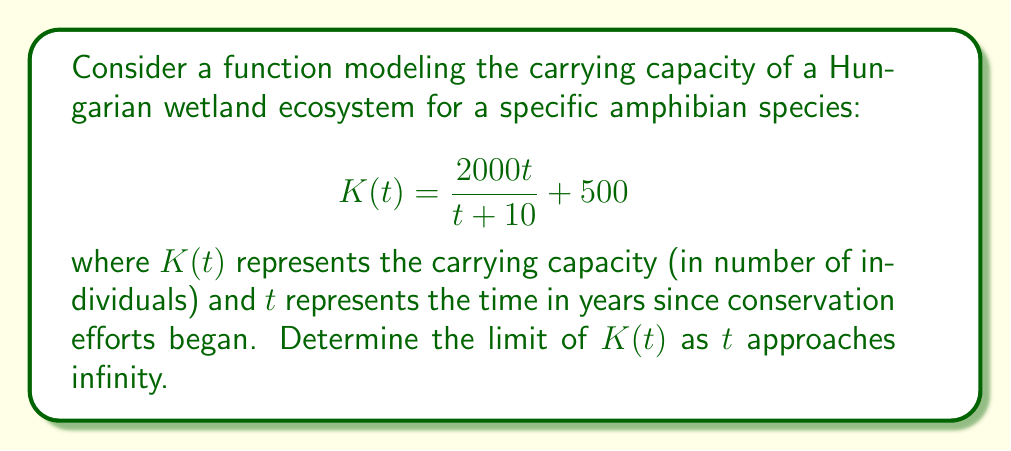Give your solution to this math problem. To find the limit of $K(t)$ as $t$ approaches infinity, we can follow these steps:

1) First, let's examine the structure of the function:
   $$K(t) = \frac{2000t}{t + 10} + 500$$

2) We can separate this into two parts:
   $$\lim_{t \to \infty} K(t) = \lim_{t \to \infty} \left(\frac{2000t}{t + 10}\right) + \lim_{t \to \infty} 500$$

3) The second limit is straightforward: $\lim_{t \to \infty} 500 = 500$

4) For the first part, we can use the following property of limits:
   $$\lim_{t \to \infty} \frac{at + b}{ct + d} = \frac{a}{c}$$ 
   where $a$, $b$, $c$, and $d$ are constants and $c \neq 0$

5) In our case, $a = 2000$, $b = 0$, $c = 1$, and $d = 10$. So:
   $$\lim_{t \to \infty} \frac{2000t}{t + 10} = \frac{2000}{1} = 2000$$

6) Combining the results from steps 3 and 5:
   $$\lim_{t \to \infty} K(t) = 2000 + 500 = 2500$$

This result suggests that as time approaches infinity, the carrying capacity of the wetland ecosystem for this amphibian species approaches 2500 individuals.
Answer: The limit of $K(t)$ as $t$ approaches infinity is 2500. 